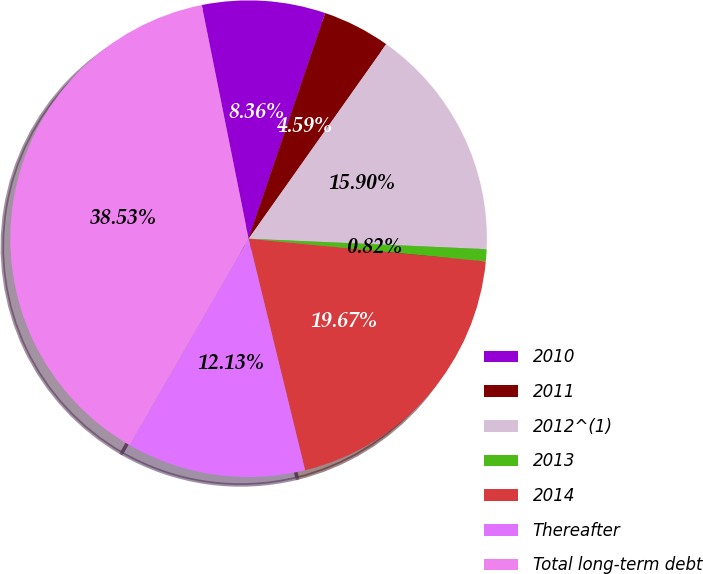<chart> <loc_0><loc_0><loc_500><loc_500><pie_chart><fcel>2010<fcel>2011<fcel>2012^(1)<fcel>2013<fcel>2014<fcel>Thereafter<fcel>Total long-term debt<nl><fcel>8.36%<fcel>4.59%<fcel>15.9%<fcel>0.82%<fcel>19.67%<fcel>12.13%<fcel>38.53%<nl></chart> 